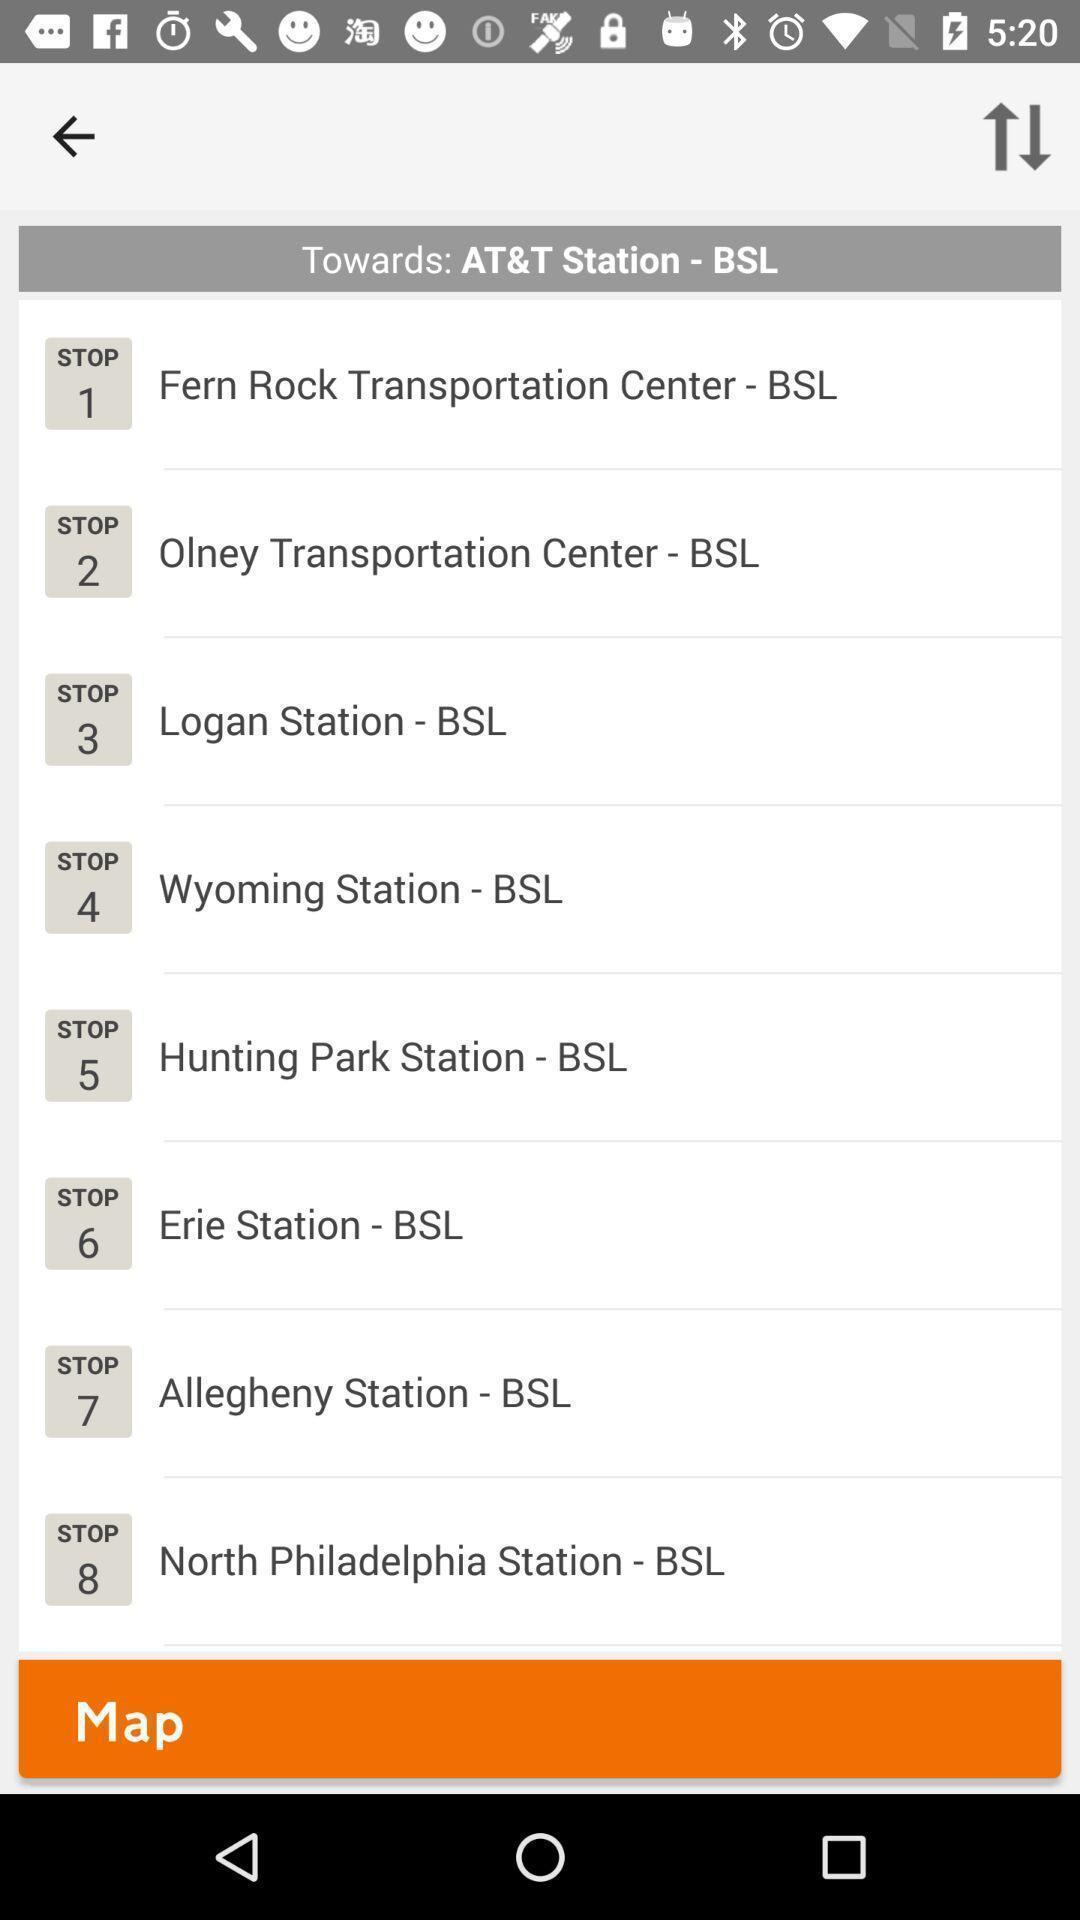What can you discern from this picture? Screen shows list of stations in a travel app. 